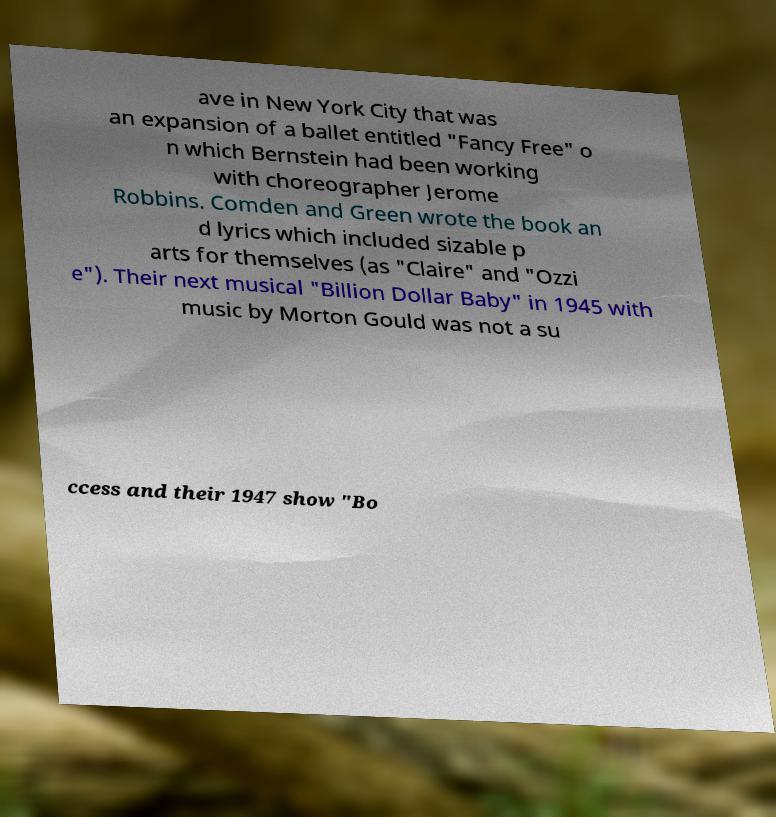Could you extract and type out the text from this image? ave in New York City that was an expansion of a ballet entitled "Fancy Free" o n which Bernstein had been working with choreographer Jerome Robbins. Comden and Green wrote the book an d lyrics which included sizable p arts for themselves (as "Claire" and "Ozzi e"). Their next musical "Billion Dollar Baby" in 1945 with music by Morton Gould was not a su ccess and their 1947 show "Bo 